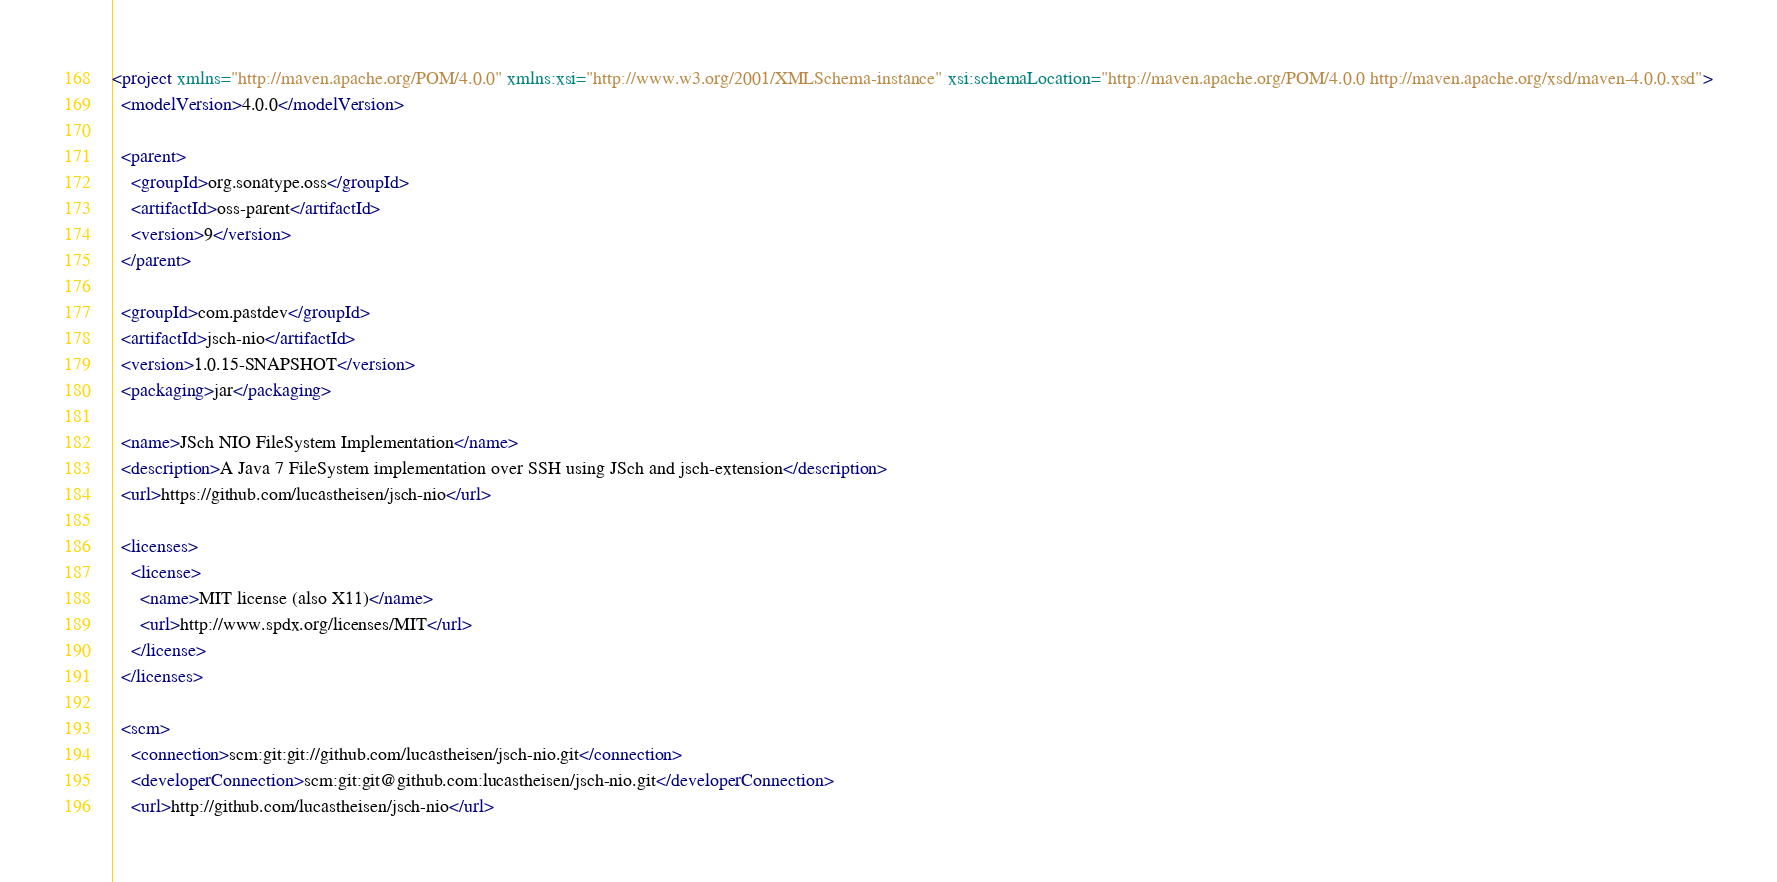<code> <loc_0><loc_0><loc_500><loc_500><_XML_><project xmlns="http://maven.apache.org/POM/4.0.0" xmlns:xsi="http://www.w3.org/2001/XMLSchema-instance" xsi:schemaLocation="http://maven.apache.org/POM/4.0.0 http://maven.apache.org/xsd/maven-4.0.0.xsd">
  <modelVersion>4.0.0</modelVersion>

  <parent>
    <groupId>org.sonatype.oss</groupId>
    <artifactId>oss-parent</artifactId>
    <version>9</version>
  </parent>

  <groupId>com.pastdev</groupId>
  <artifactId>jsch-nio</artifactId>
  <version>1.0.15-SNAPSHOT</version>
  <packaging>jar</packaging>

  <name>JSch NIO FileSystem Implementation</name>
  <description>A Java 7 FileSystem implementation over SSH using JSch and jsch-extension</description>
  <url>https://github.com/lucastheisen/jsch-nio</url>

  <licenses>
    <license>
      <name>MIT license (also X11)</name>
      <url>http://www.spdx.org/licenses/MIT</url>
    </license>
  </licenses>

  <scm>
    <connection>scm:git:git://github.com/lucastheisen/jsch-nio.git</connection>
    <developerConnection>scm:git:git@github.com:lucastheisen/jsch-nio.git</developerConnection>
    <url>http://github.com/lucastheisen/jsch-nio</url></code> 